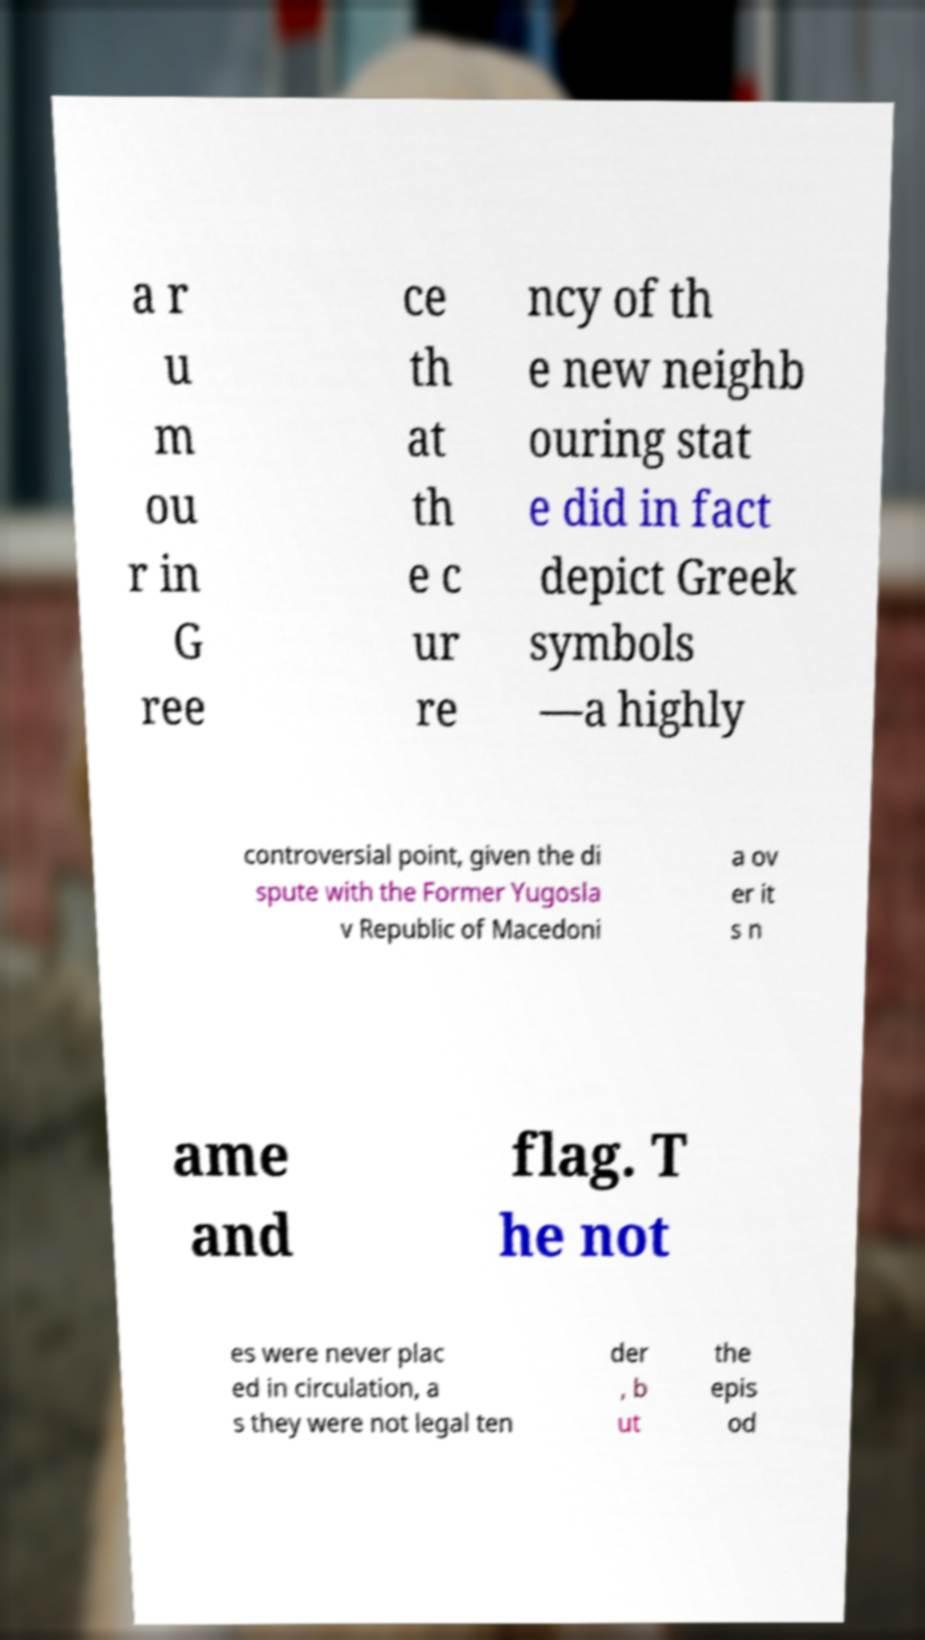Please read and relay the text visible in this image. What does it say? a r u m ou r in G ree ce th at th e c ur re ncy of th e new neighb ouring stat e did in fact depict Greek symbols —a highly controversial point, given the di spute with the Former Yugosla v Republic of Macedoni a ov er it s n ame and flag. T he not es were never plac ed in circulation, a s they were not legal ten der , b ut the epis od 